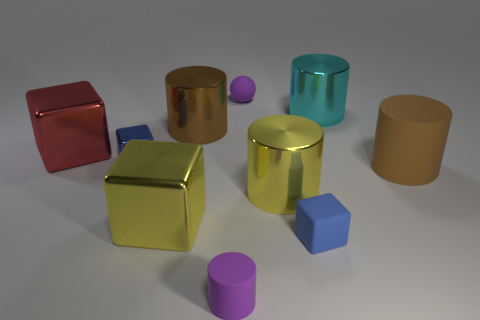Subtract all big yellow cubes. How many cubes are left? 3 Subtract all yellow blocks. How many blocks are left? 3 Subtract all balls. How many objects are left? 9 Subtract all green balls. How many yellow cubes are left? 1 Subtract all big purple things. Subtract all big shiny objects. How many objects are left? 5 Add 1 tiny rubber cubes. How many tiny rubber cubes are left? 2 Add 3 metallic objects. How many metallic objects exist? 9 Subtract 1 blue cubes. How many objects are left? 9 Subtract 2 cylinders. How many cylinders are left? 3 Subtract all green cylinders. Subtract all yellow cubes. How many cylinders are left? 5 